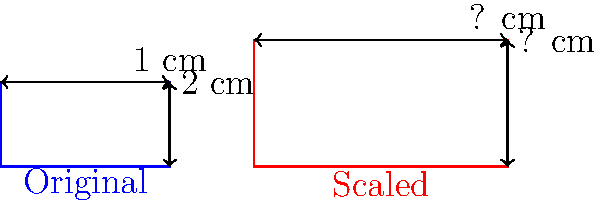The scroll of a cello is a distinctive feature at the top of the instrument. If the original scroll measures 2 cm in width and 1 cm in height, and it is scaled up by a factor of 1.5, what are the new dimensions of the scroll? To find the new dimensions of the scaled scroll, we need to multiply the original dimensions by the scaling factor. Let's go through this step-by-step:

1. Original dimensions:
   Width = 2 cm
   Height = 1 cm

2. Scaling factor = 1.5

3. Calculate new width:
   New width = Original width × Scaling factor
   New width = 2 cm × 1.5 = 3 cm

4. Calculate new height:
   New height = Original height × Scaling factor
   New height = 1 cm × 1.5 = 1.5 cm

Therefore, after scaling by a factor of 1.5, the new dimensions of the scroll are 3 cm in width and 1.5 cm in height.
Answer: 3 cm × 1.5 cm 